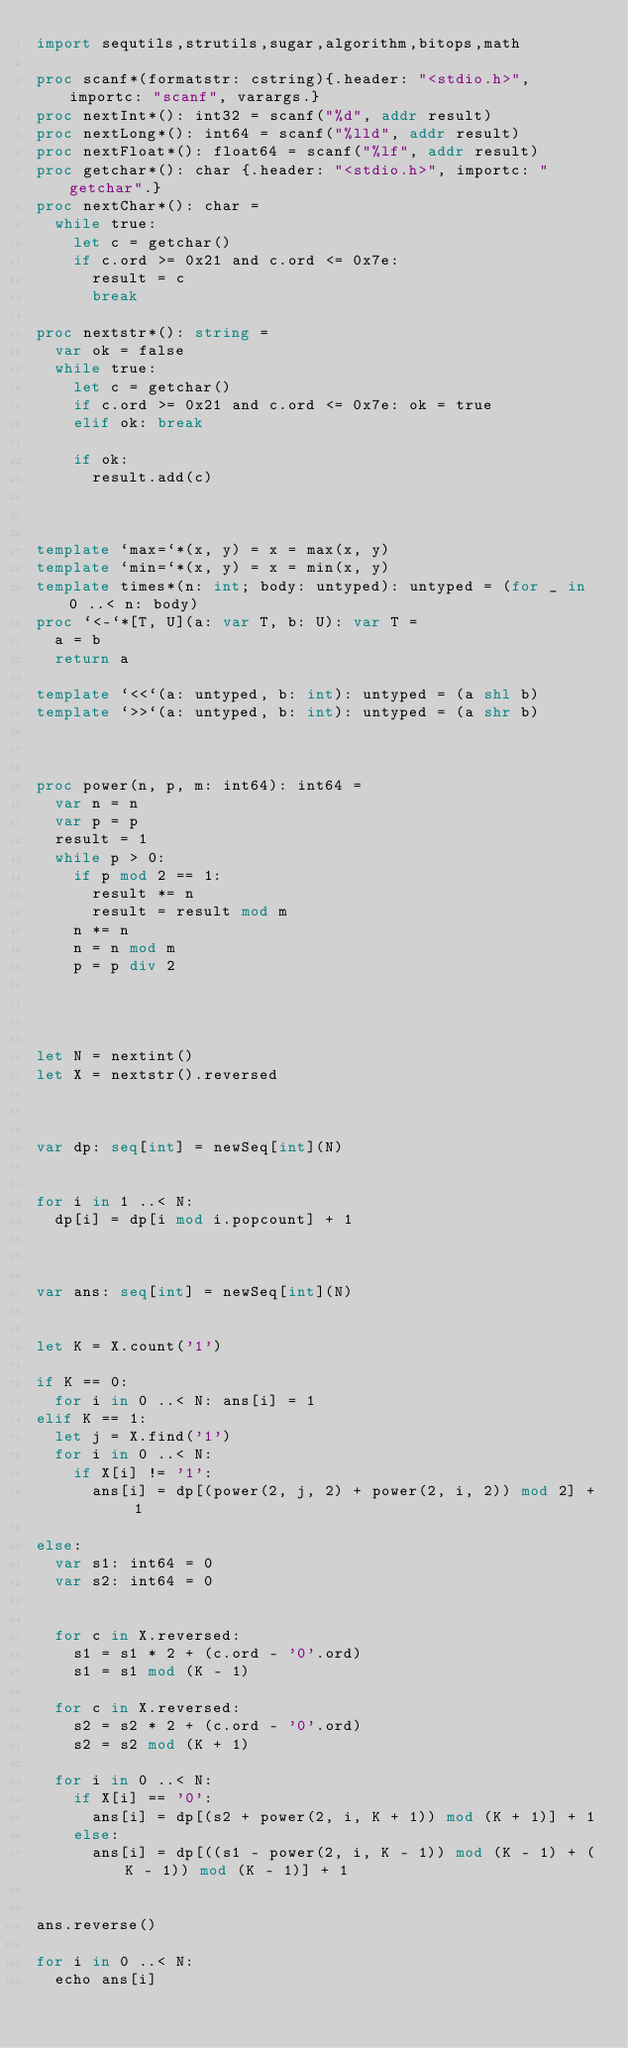Convert code to text. <code><loc_0><loc_0><loc_500><loc_500><_Nim_>import sequtils,strutils,sugar,algorithm,bitops,math

proc scanf*(formatstr: cstring){.header: "<stdio.h>", importc: "scanf", varargs.}
proc nextInt*(): int32 = scanf("%d", addr result)
proc nextLong*(): int64 = scanf("%lld", addr result)
proc nextFloat*(): float64 = scanf("%lf", addr result)
proc getchar*(): char {.header: "<stdio.h>", importc: "getchar".}
proc nextChar*(): char =
  while true:
    let c = getchar()
    if c.ord >= 0x21 and c.ord <= 0x7e:
      result = c
      break

proc nextstr*(): string =
  var ok = false
  while true:
    let c = getchar()
    if c.ord >= 0x21 and c.ord <= 0x7e: ok = true
    elif ok: break

    if ok:
      result.add(c)
      


template `max=`*(x, y) = x = max(x, y)
template `min=`*(x, y) = x = min(x, y)
template times*(n: int; body: untyped): untyped = (for _ in 0 ..< n: body)
proc `<-`*[T, U](a: var T, b: U): var T =
  a = b
  return a

template `<<`(a: untyped, b: int): untyped = (a shl b)
template `>>`(a: untyped, b: int): untyped = (a shr b)



proc power(n, p, m: int64): int64 =
  var n = n
  var p = p
  result = 1
  while p > 0:
    if p mod 2 == 1:
      result *= n
      result = result mod m
    n *= n
    n = n mod m
    p = p div 2




let N = nextint()
let X = nextstr().reversed



var dp: seq[int] = newSeq[int](N)


for i in 1 ..< N:
  dp[i] = dp[i mod i.popcount] + 1



var ans: seq[int] = newSeq[int](N)


let K = X.count('1')

if K == 0:
  for i in 0 ..< N: ans[i] = 1
elif K == 1:
  let j = X.find('1')
  for i in 0 ..< N:
    if X[i] != '1':
      ans[i] = dp[(power(2, j, 2) + power(2, i, 2)) mod 2] + 1

else:
  var s1: int64 = 0
  var s2: int64 = 0


  for c in X.reversed:
    s1 = s1 * 2 + (c.ord - '0'.ord)
    s1 = s1 mod (K - 1)

  for c in X.reversed:
    s2 = s2 * 2 + (c.ord - '0'.ord)
    s2 = s2 mod (K + 1)

  for i in 0 ..< N:
    if X[i] == '0':
      ans[i] = dp[(s2 + power(2, i, K + 1)) mod (K + 1)] + 1
    else:
      ans[i] = dp[((s1 - power(2, i, K - 1)) mod (K - 1) + (K - 1)) mod (K - 1)] + 1
  

ans.reverse()
    
for i in 0 ..< N:
  echo ans[i]

</code> 